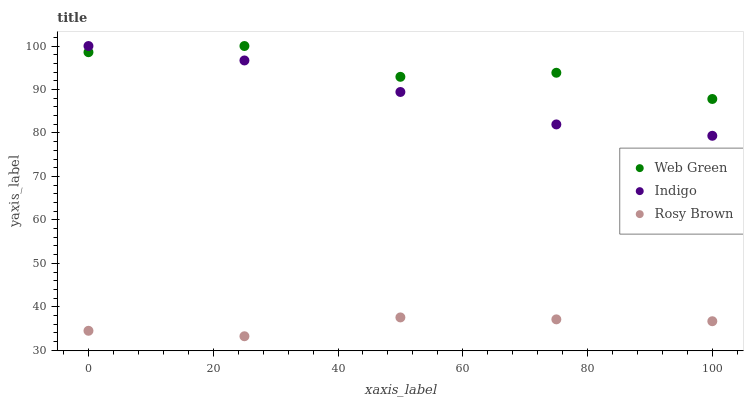Does Rosy Brown have the minimum area under the curve?
Answer yes or no. Yes. Does Web Green have the maximum area under the curve?
Answer yes or no. Yes. Does Indigo have the minimum area under the curve?
Answer yes or no. No. Does Indigo have the maximum area under the curve?
Answer yes or no. No. Is Indigo the smoothest?
Answer yes or no. Yes. Is Web Green the roughest?
Answer yes or no. Yes. Is Web Green the smoothest?
Answer yes or no. No. Is Indigo the roughest?
Answer yes or no. No. Does Rosy Brown have the lowest value?
Answer yes or no. Yes. Does Indigo have the lowest value?
Answer yes or no. No. Does Web Green have the highest value?
Answer yes or no. Yes. Is Rosy Brown less than Indigo?
Answer yes or no. Yes. Is Indigo greater than Rosy Brown?
Answer yes or no. Yes. Does Indigo intersect Web Green?
Answer yes or no. Yes. Is Indigo less than Web Green?
Answer yes or no. No. Is Indigo greater than Web Green?
Answer yes or no. No. Does Rosy Brown intersect Indigo?
Answer yes or no. No. 